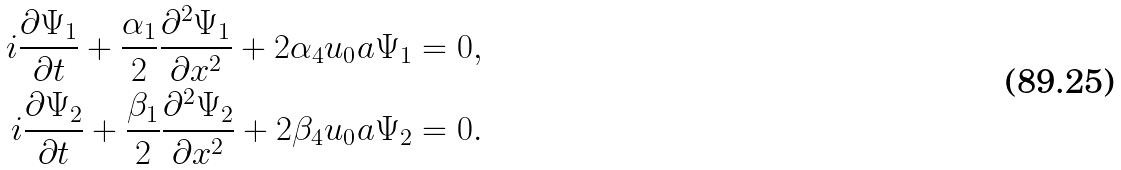<formula> <loc_0><loc_0><loc_500><loc_500>i \frac { \partial \Psi _ { 1 } } { \partial t } + \frac { \alpha _ { 1 } } { 2 } \frac { \partial ^ { 2 } \Psi _ { 1 } } { \partial x ^ { 2 } } + 2 \alpha _ { 4 } u _ { 0 } a \Psi _ { 1 } = 0 , \\ i \frac { \partial \Psi _ { 2 } } { \partial t } + \frac { \beta _ { 1 } } { 2 } \frac { \partial ^ { 2 } \Psi _ { 2 } } { \partial x ^ { 2 } } + 2 \beta _ { 4 } u _ { 0 } a \Psi _ { 2 } = 0 .</formula> 